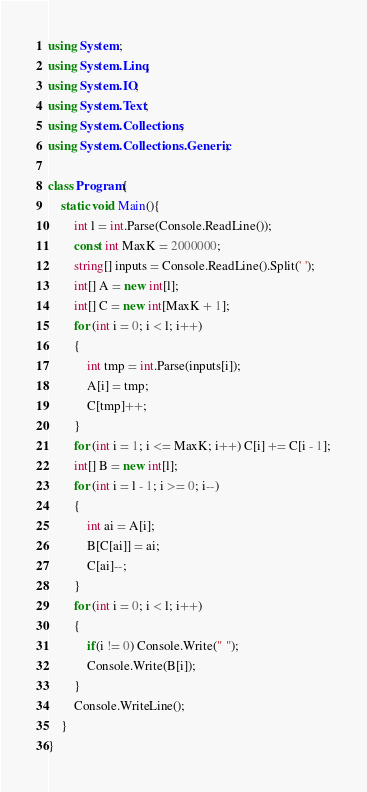<code> <loc_0><loc_0><loc_500><loc_500><_C#_>using System;
using System.Linq;
using System.IO;
using System.Text;
using System.Collections;
using System.Collections.Generic;
 
class Program{
    static void Main(){
        int l = int.Parse(Console.ReadLine());
        const int MaxK = 2000000;
        string[] inputs = Console.ReadLine().Split(' ');
        int[] A = new int[l];
        int[] C = new int[MaxK + 1];
        for (int i = 0; i < l; i++)
        {
            int tmp = int.Parse(inputs[i]);
            A[i] = tmp;
            C[tmp]++;
        }
        for (int i = 1; i <= MaxK; i++) C[i] += C[i - 1];
        int[] B = new int[l];
        for (int i = l - 1; i >= 0; i--)
        {
            int ai = A[i];
            B[C[ai]] = ai;
            C[ai]--;
        }
        for (int i = 0; i < l; i++)
        {
            if(i != 0) Console.Write(" ");
            Console.Write(B[i]);
        }
        Console.WriteLine();
    }
}</code> 